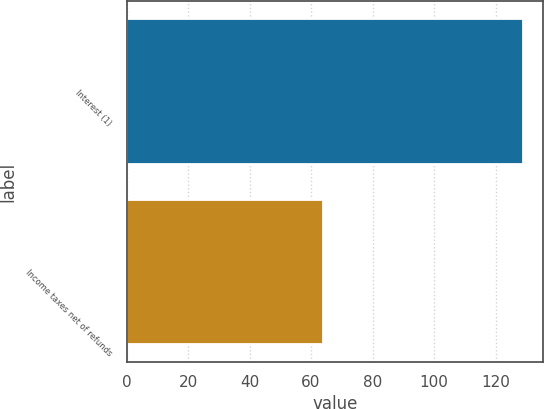<chart> <loc_0><loc_0><loc_500><loc_500><bar_chart><fcel>Interest (1)<fcel>Income taxes net of refunds<nl><fcel>129<fcel>64<nl></chart> 